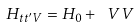<formula> <loc_0><loc_0><loc_500><loc_500>H _ { t t ^ { \prime } V } = H _ { 0 } + \ V V</formula> 